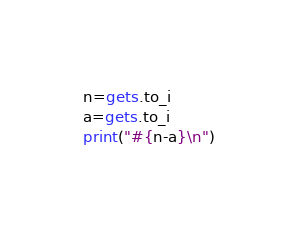<code> <loc_0><loc_0><loc_500><loc_500><_Ruby_>n=gets.to_i
a=gets.to_i
print("#{n-a}\n")</code> 